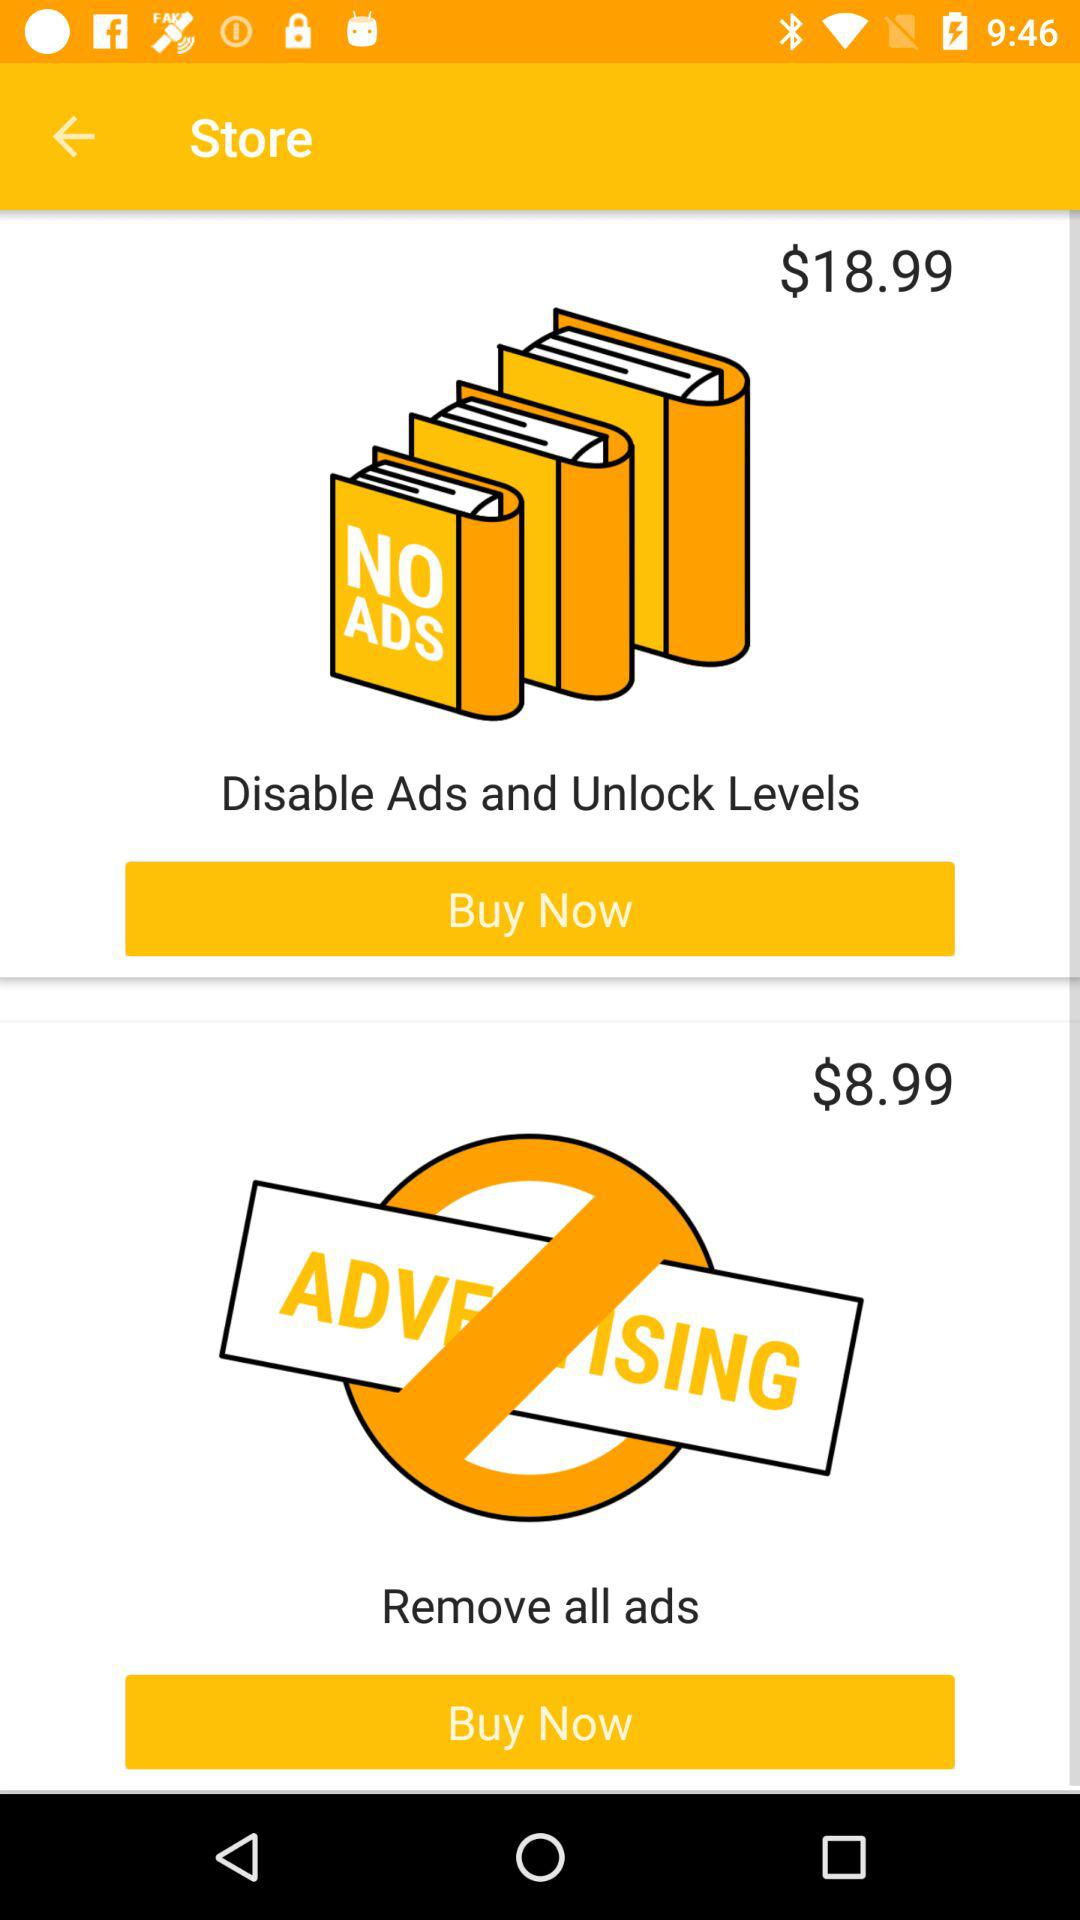What is the name of the application?
When the provided information is insufficient, respond with <no answer>. <no answer> 